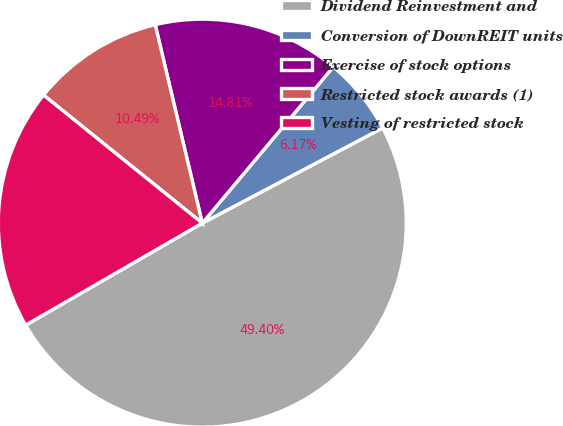Convert chart. <chart><loc_0><loc_0><loc_500><loc_500><pie_chart><fcel>Dividend Reinvestment and<fcel>Conversion of DownREIT units<fcel>Exercise of stock options<fcel>Restricted stock awards (1)<fcel>Vesting of restricted stock<nl><fcel>49.4%<fcel>6.17%<fcel>14.81%<fcel>10.49%<fcel>19.14%<nl></chart> 